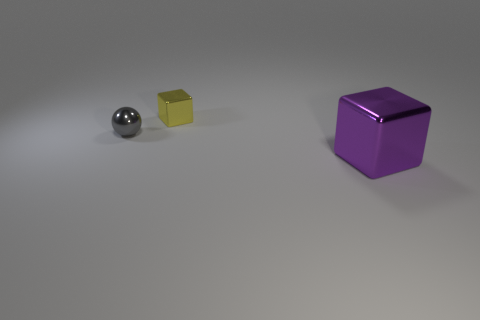Add 1 metal blocks. How many objects exist? 4 Subtract all balls. How many objects are left? 2 Subtract all tiny brown cylinders. Subtract all tiny yellow things. How many objects are left? 2 Add 2 yellow metallic things. How many yellow metallic things are left? 3 Add 3 tiny balls. How many tiny balls exist? 4 Subtract 0 blue blocks. How many objects are left? 3 